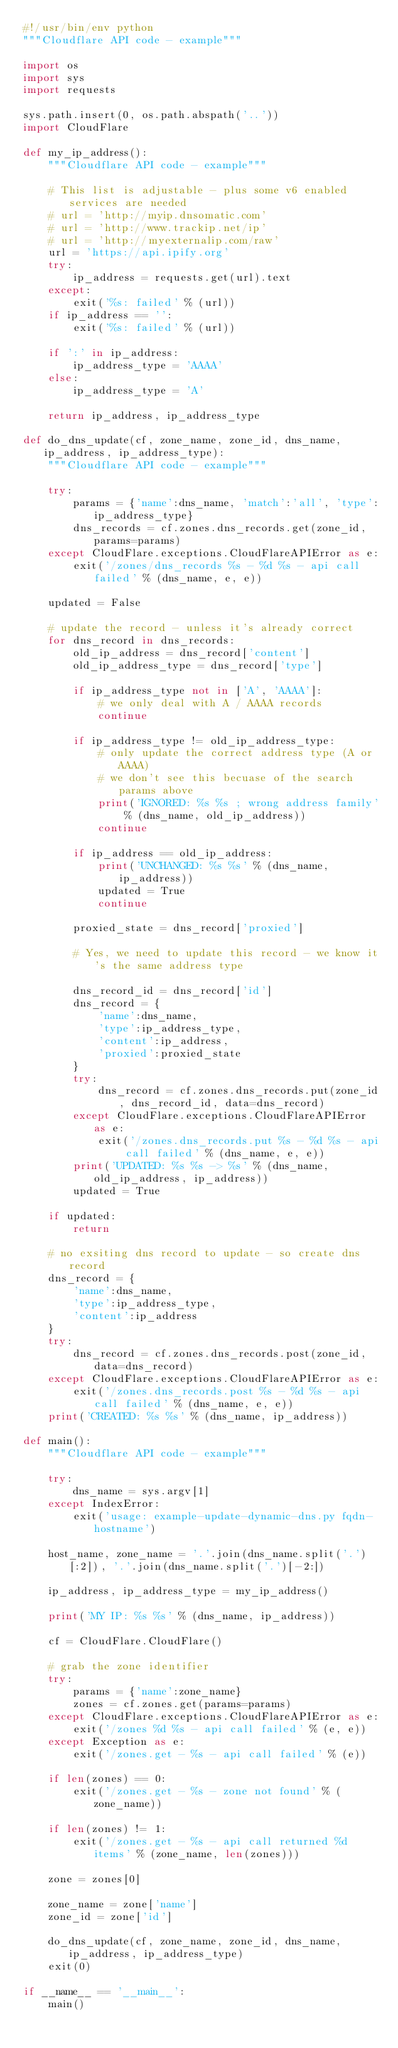<code> <loc_0><loc_0><loc_500><loc_500><_Python_>#!/usr/bin/env python
"""Cloudflare API code - example"""

import os
import sys
import requests

sys.path.insert(0, os.path.abspath('..'))
import CloudFlare

def my_ip_address():
    """Cloudflare API code - example"""

    # This list is adjustable - plus some v6 enabled services are needed
    # url = 'http://myip.dnsomatic.com'
    # url = 'http://www.trackip.net/ip'
    # url = 'http://myexternalip.com/raw'
    url = 'https://api.ipify.org'
    try:
        ip_address = requests.get(url).text
    except:
        exit('%s: failed' % (url))
    if ip_address == '':
        exit('%s: failed' % (url))

    if ':' in ip_address:
        ip_address_type = 'AAAA'
    else:
        ip_address_type = 'A'

    return ip_address, ip_address_type

def do_dns_update(cf, zone_name, zone_id, dns_name, ip_address, ip_address_type):
    """Cloudflare API code - example"""

    try:
        params = {'name':dns_name, 'match':'all', 'type':ip_address_type}
        dns_records = cf.zones.dns_records.get(zone_id, params=params)
    except CloudFlare.exceptions.CloudFlareAPIError as e:
        exit('/zones/dns_records %s - %d %s - api call failed' % (dns_name, e, e))

    updated = False

    # update the record - unless it's already correct
    for dns_record in dns_records:
        old_ip_address = dns_record['content']
        old_ip_address_type = dns_record['type']

        if ip_address_type not in ['A', 'AAAA']:
            # we only deal with A / AAAA records
            continue

        if ip_address_type != old_ip_address_type:
            # only update the correct address type (A or AAAA)
            # we don't see this becuase of the search params above
            print('IGNORED: %s %s ; wrong address family' % (dns_name, old_ip_address))
            continue

        if ip_address == old_ip_address:
            print('UNCHANGED: %s %s' % (dns_name, ip_address))
            updated = True
            continue

        proxied_state = dns_record['proxied']
 
        # Yes, we need to update this record - we know it's the same address type

        dns_record_id = dns_record['id']
        dns_record = {
            'name':dns_name,
            'type':ip_address_type,
            'content':ip_address,
            'proxied':proxied_state
        }
        try:
            dns_record = cf.zones.dns_records.put(zone_id, dns_record_id, data=dns_record)
        except CloudFlare.exceptions.CloudFlareAPIError as e:
            exit('/zones.dns_records.put %s - %d %s - api call failed' % (dns_name, e, e))
        print('UPDATED: %s %s -> %s' % (dns_name, old_ip_address, ip_address))
        updated = True

    if updated:
        return

    # no exsiting dns record to update - so create dns record
    dns_record = {
        'name':dns_name,
        'type':ip_address_type,
        'content':ip_address
    }
    try:
        dns_record = cf.zones.dns_records.post(zone_id, data=dns_record)
    except CloudFlare.exceptions.CloudFlareAPIError as e:
        exit('/zones.dns_records.post %s - %d %s - api call failed' % (dns_name, e, e))
    print('CREATED: %s %s' % (dns_name, ip_address))

def main():
    """Cloudflare API code - example"""

    try:
        dns_name = sys.argv[1]
    except IndexError:
        exit('usage: example-update-dynamic-dns.py fqdn-hostname')

    host_name, zone_name = '.'.join(dns_name.split('.')[:2]), '.'.join(dns_name.split('.')[-2:])

    ip_address, ip_address_type = my_ip_address()

    print('MY IP: %s %s' % (dns_name, ip_address))

    cf = CloudFlare.CloudFlare()

    # grab the zone identifier
    try:
        params = {'name':zone_name}
        zones = cf.zones.get(params=params)
    except CloudFlare.exceptions.CloudFlareAPIError as e:
        exit('/zones %d %s - api call failed' % (e, e))
    except Exception as e:
        exit('/zones.get - %s - api call failed' % (e))

    if len(zones) == 0:
        exit('/zones.get - %s - zone not found' % (zone_name))

    if len(zones) != 1:
        exit('/zones.get - %s - api call returned %d items' % (zone_name, len(zones)))

    zone = zones[0]

    zone_name = zone['name']
    zone_id = zone['id']

    do_dns_update(cf, zone_name, zone_id, dns_name, ip_address, ip_address_type)
    exit(0)

if __name__ == '__main__':
    main()

</code> 